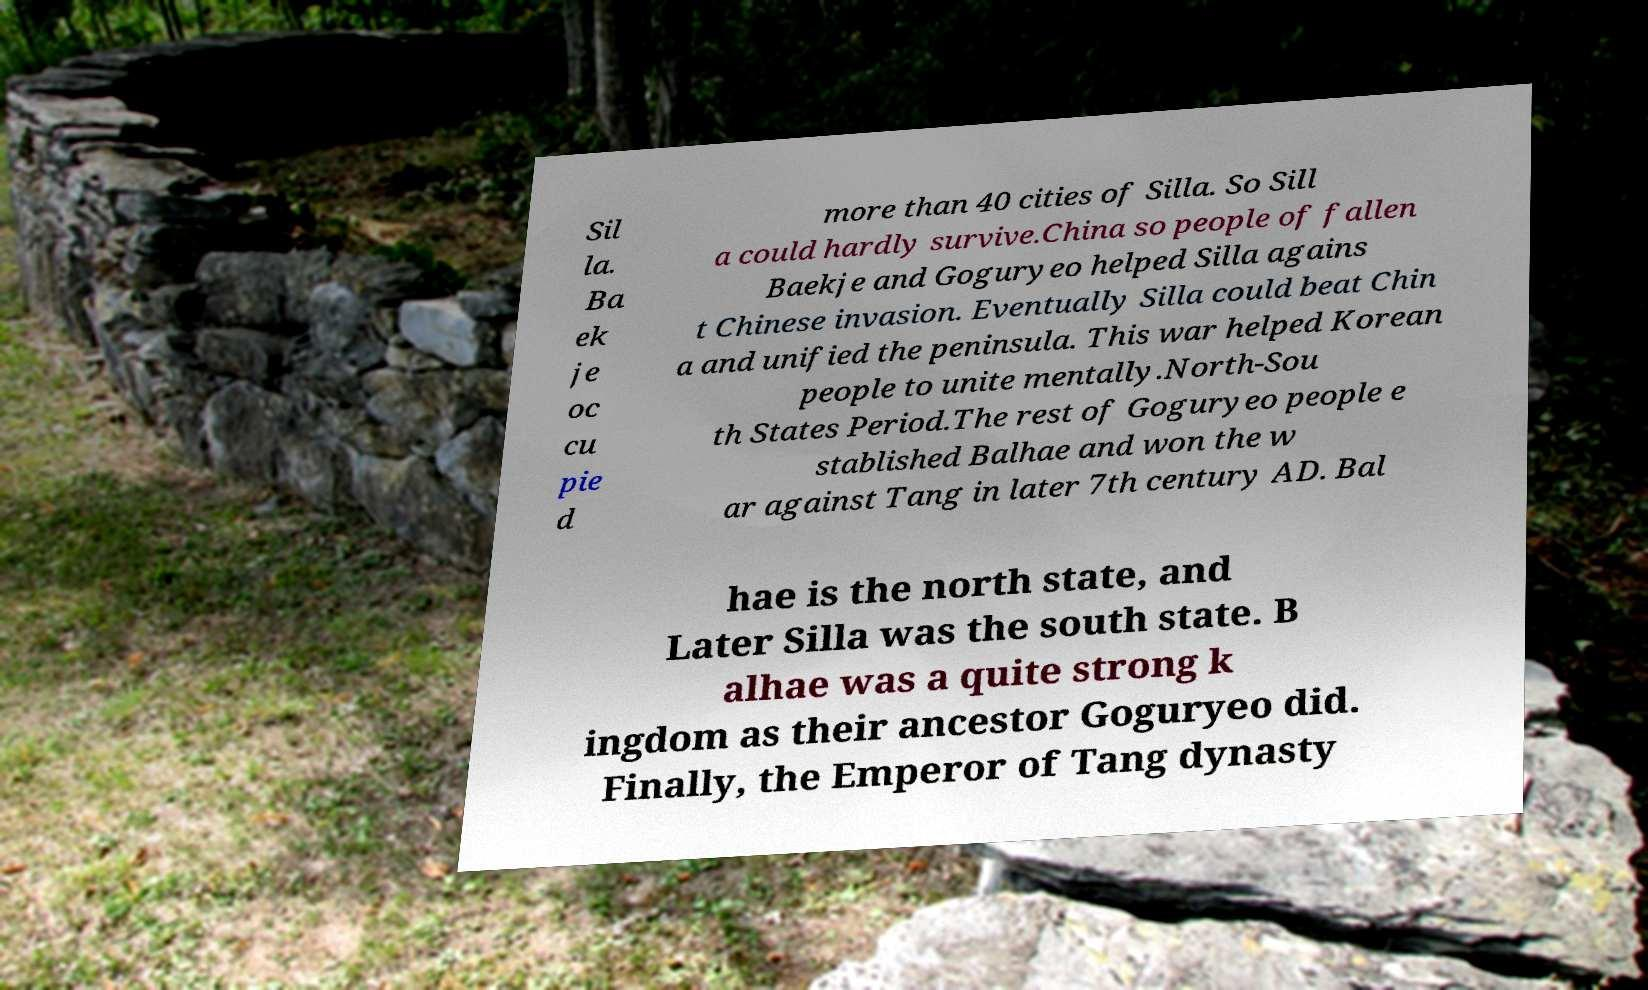Could you assist in decoding the text presented in this image and type it out clearly? Sil la. Ba ek je oc cu pie d more than 40 cities of Silla. So Sill a could hardly survive.China so people of fallen Baekje and Goguryeo helped Silla agains t Chinese invasion. Eventually Silla could beat Chin a and unified the peninsula. This war helped Korean people to unite mentally.North-Sou th States Period.The rest of Goguryeo people e stablished Balhae and won the w ar against Tang in later 7th century AD. Bal hae is the north state, and Later Silla was the south state. B alhae was a quite strong k ingdom as their ancestor Goguryeo did. Finally, the Emperor of Tang dynasty 